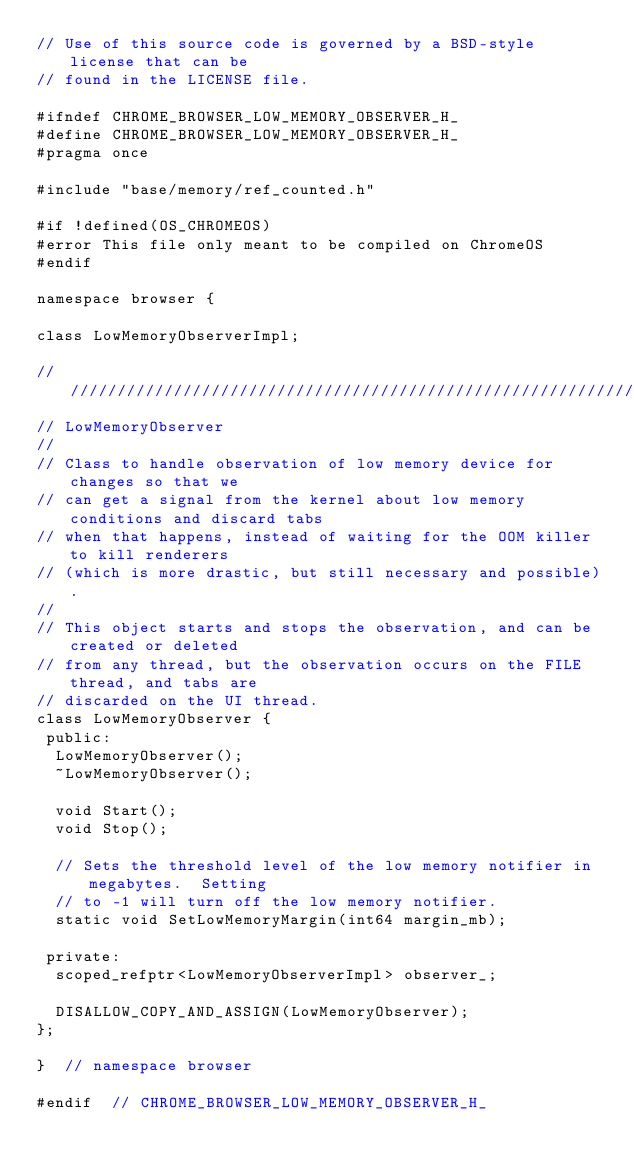<code> <loc_0><loc_0><loc_500><loc_500><_C_>// Use of this source code is governed by a BSD-style license that can be
// found in the LICENSE file.

#ifndef CHROME_BROWSER_LOW_MEMORY_OBSERVER_H_
#define CHROME_BROWSER_LOW_MEMORY_OBSERVER_H_
#pragma once

#include "base/memory/ref_counted.h"

#if !defined(OS_CHROMEOS)
#error This file only meant to be compiled on ChromeOS
#endif

namespace browser {

class LowMemoryObserverImpl;

////////////////////////////////////////////////////////////////////////////////
// LowMemoryObserver
//
// Class to handle observation of low memory device for changes so that we
// can get a signal from the kernel about low memory conditions and discard tabs
// when that happens, instead of waiting for the OOM killer to kill renderers
// (which is more drastic, but still necessary and possible).
//
// This object starts and stops the observation, and can be created or deleted
// from any thread, but the observation occurs on the FILE thread, and tabs are
// discarded on the UI thread.
class LowMemoryObserver {
 public:
  LowMemoryObserver();
  ~LowMemoryObserver();

  void Start();
  void Stop();

  // Sets the threshold level of the low memory notifier in megabytes.  Setting
  // to -1 will turn off the low memory notifier.
  static void SetLowMemoryMargin(int64 margin_mb);

 private:
  scoped_refptr<LowMemoryObserverImpl> observer_;

  DISALLOW_COPY_AND_ASSIGN(LowMemoryObserver);
};

}  // namespace browser

#endif  // CHROME_BROWSER_LOW_MEMORY_OBSERVER_H_
</code> 